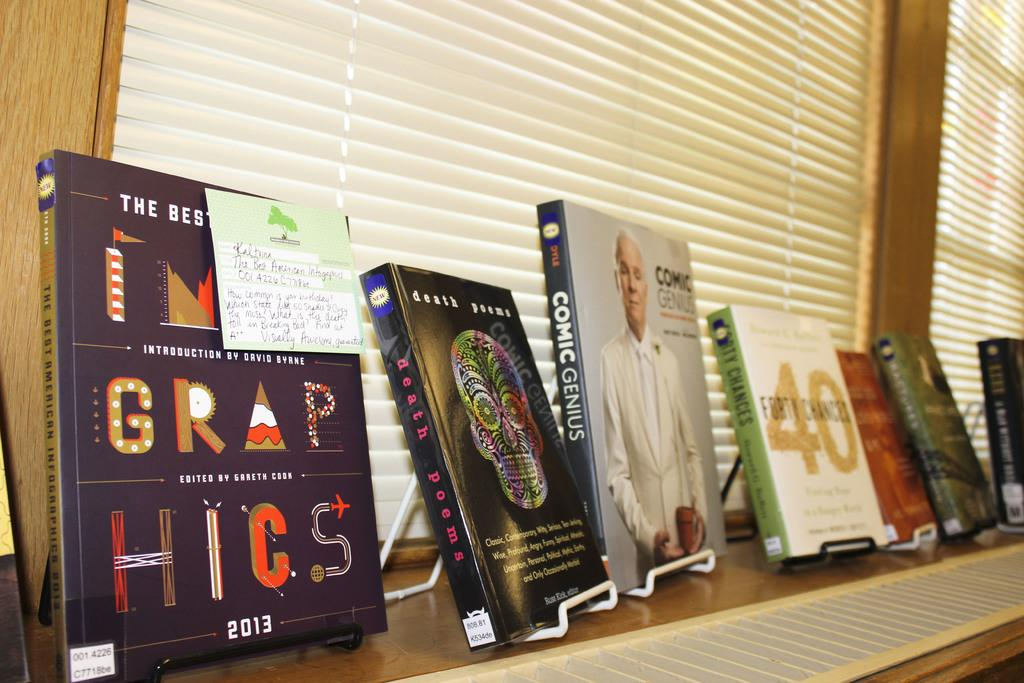<image>
Present a compact description of the photo's key features. A book titled death poems is on display. 